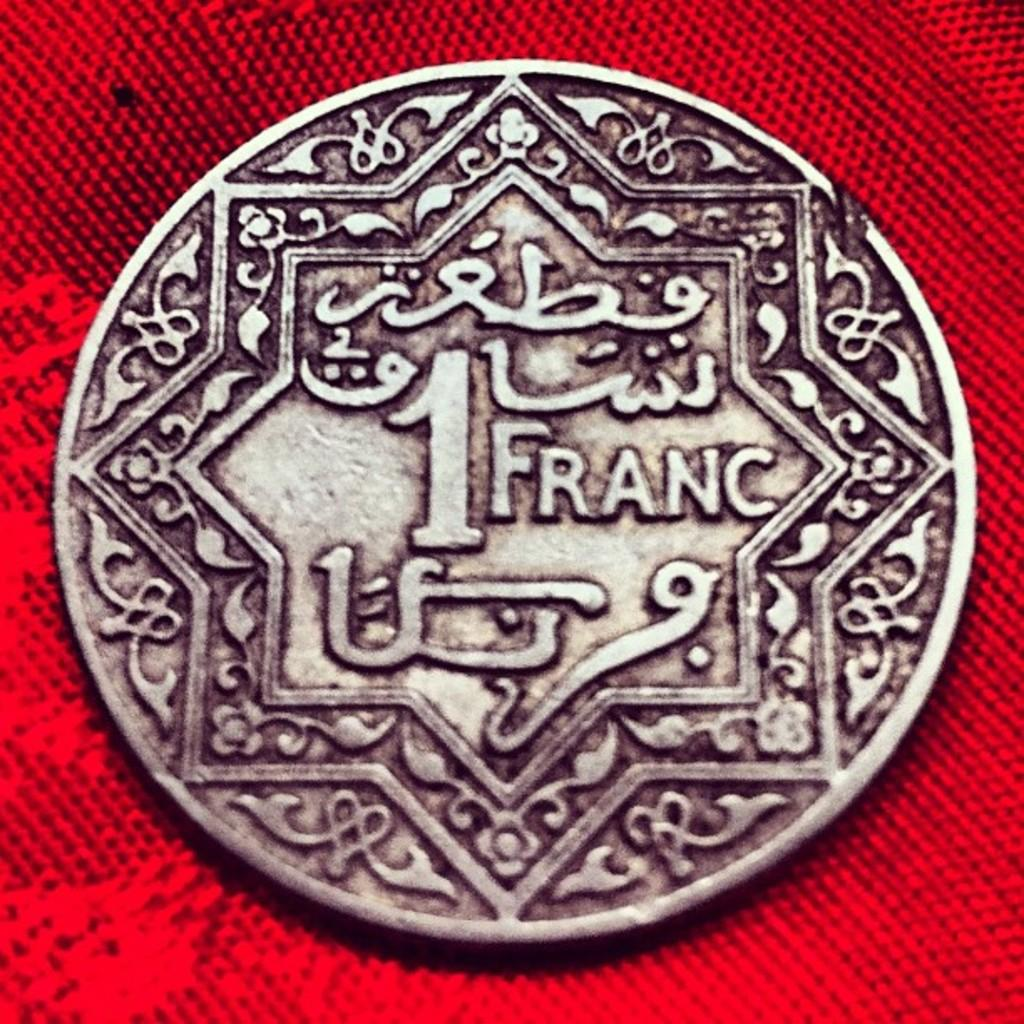<image>
Offer a succinct explanation of the picture presented. one round silver coin value at one franc 